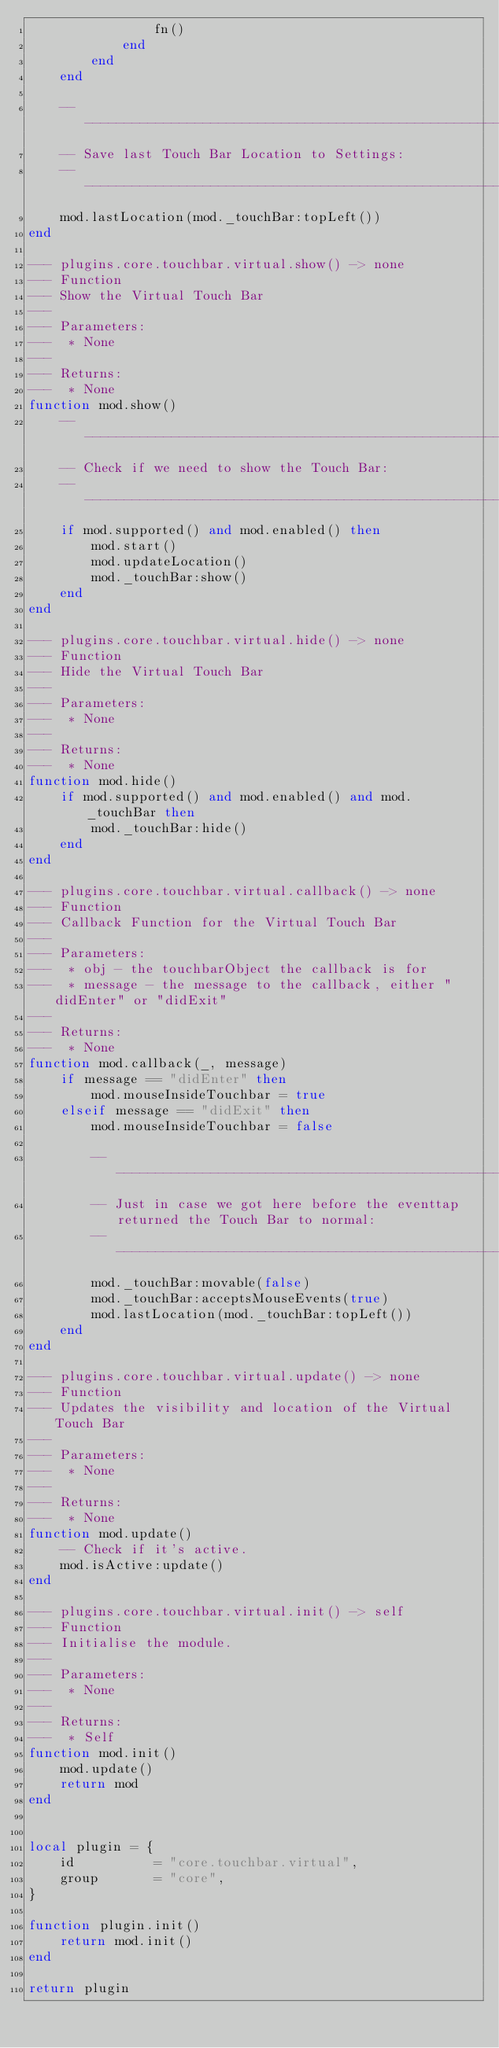Convert code to text. <code><loc_0><loc_0><loc_500><loc_500><_Lua_>                fn()
            end
        end
    end

    --------------------------------------------------------------------------------
    -- Save last Touch Bar Location to Settings:
    --------------------------------------------------------------------------------
    mod.lastLocation(mod._touchBar:topLeft())
end

--- plugins.core.touchbar.virtual.show() -> none
--- Function
--- Show the Virtual Touch Bar
---
--- Parameters:
---  * None
---
--- Returns:
---  * None
function mod.show()
    --------------------------------------------------------------------------------
    -- Check if we need to show the Touch Bar:
    --------------------------------------------------------------------------------
    if mod.supported() and mod.enabled() then
        mod.start()
        mod.updateLocation()
        mod._touchBar:show()
    end
end

--- plugins.core.touchbar.virtual.hide() -> none
--- Function
--- Hide the Virtual Touch Bar
---
--- Parameters:
---  * None
---
--- Returns:
---  * None
function mod.hide()
    if mod.supported() and mod.enabled() and mod._touchBar then
        mod._touchBar:hide()
    end
end

--- plugins.core.touchbar.virtual.callback() -> none
--- Function
--- Callback Function for the Virtual Touch Bar
---
--- Parameters:
---  * obj - the touchbarObject the callback is for
---  * message - the message to the callback, either "didEnter" or "didExit"
---
--- Returns:
---  * None
function mod.callback(_, message)
    if message == "didEnter" then
        mod.mouseInsideTouchbar = true
    elseif message == "didExit" then
        mod.mouseInsideTouchbar = false

        --------------------------------------------------------------------------------
        -- Just in case we got here before the eventtap returned the Touch Bar to normal:
        --------------------------------------------------------------------------------
        mod._touchBar:movable(false)
        mod._touchBar:acceptsMouseEvents(true)
        mod.lastLocation(mod._touchBar:topLeft())
    end
end

--- plugins.core.touchbar.virtual.update() -> none
--- Function
--- Updates the visibility and location of the Virtual Touch Bar
---
--- Parameters:
---  * None
---
--- Returns:
---  * None
function mod.update()
    -- Check if it's active.
    mod.isActive:update()
end

--- plugins.core.touchbar.virtual.init() -> self
--- Function
--- Initialise the module.
---
--- Parameters:
---  * None
---
--- Returns:
---  * Self
function mod.init()
    mod.update()
    return mod
end


local plugin = {
    id          = "core.touchbar.virtual",
    group       = "core",
}

function plugin.init()
    return mod.init()
end

return plugin
</code> 